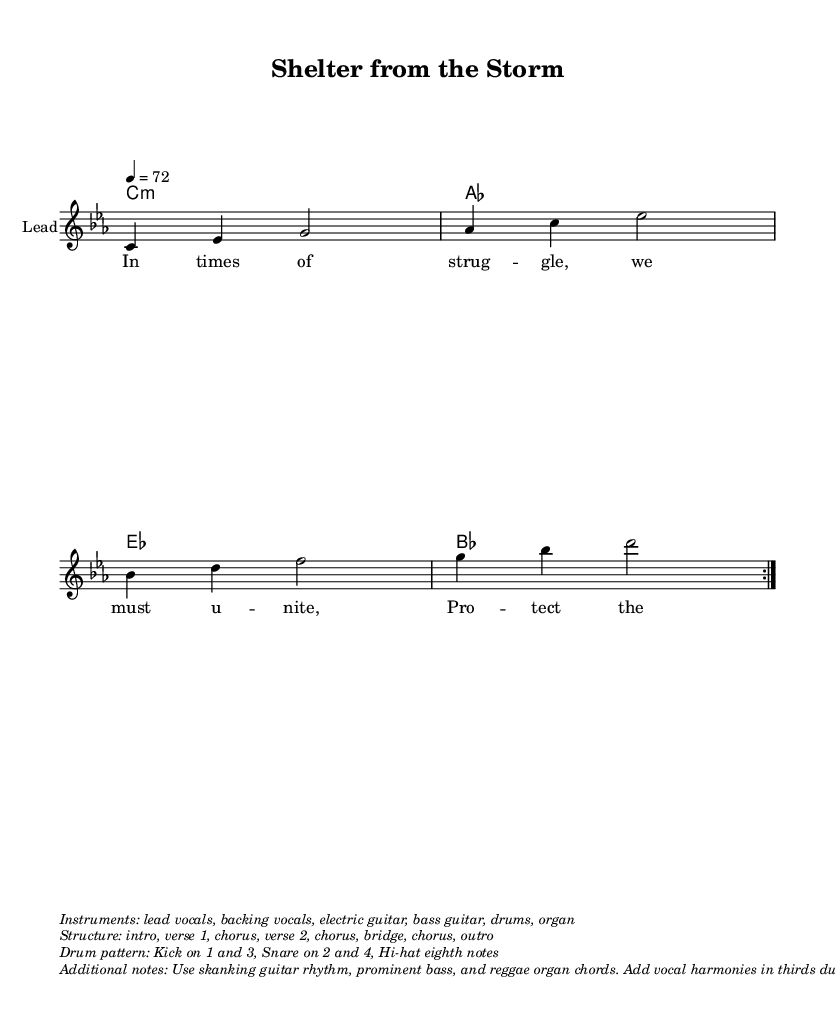What is the key signature of this music? The key signature indicated at the beginning of the staff shows that the music is in C minor, which includes three flats (B♭, E♭, and A♭).
Answer: C minor What is the time signature of this music? The time signature is located at the beginning of the staff, and it indicates that the music has a four beats per measure structure, written as 4/4.
Answer: 4/4 What is the tempo marking given in the score? The tempo marking at the beginning indicates that the music should be played at a speed of 72 beats per minute, written as 4 = 72.
Answer: 72 How many times is the melody section repeated? The melody section is marked with "volta 2," indicating that it is intended to be repeated two times in total.
Answer: 2 What instruments are indicated to be used in the performance? The music provides a list in the markup indicating that lead vocals, backing vocals, electric guitar, bass guitar, drums, and organ should be used.
Answer: Lead vocals, backing vocals, electric guitar, bass guitar, drums, organ What is the structure of the song according to the markup? The structure, as detailed in the markup, indicates that the song follows an order of intro, verse 1, chorus, verse 2, chorus, bridge, chorus, and outro.
Answer: Intro, verse 1, chorus, verse 2, chorus, bridge, chorus, outro What kind of drum pattern is specified for the music? The drum pattern described in the markup notes that the kick drum plays on the first and third beats, while the snare drum plays on the second and fourth beats, with hi-hat playing eighth notes.
Answer: Kick on 1 and 3, Snare on 2 and 4, Hi-hat eighth notes 